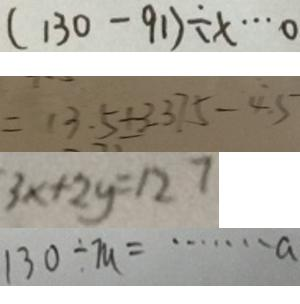<formula> <loc_0><loc_0><loc_500><loc_500>( 1 3 0 - 9 1 ) \div x \cdots 0 
 = 1 3 . 5 + 3 . 3 7 5 - 4 . 5 
 3 x + 2 y = 1 2 7 
 1 3 0 \div m = \cdots a</formula> 